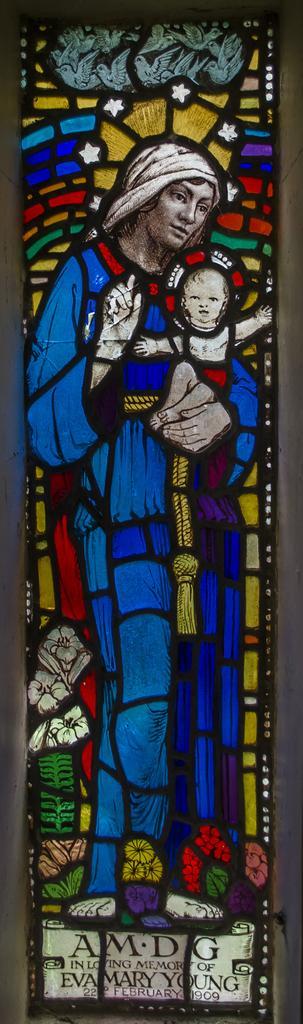Describe this image in one or two sentences. In this image I can see a stained glass. At the bottom I can see some text. 